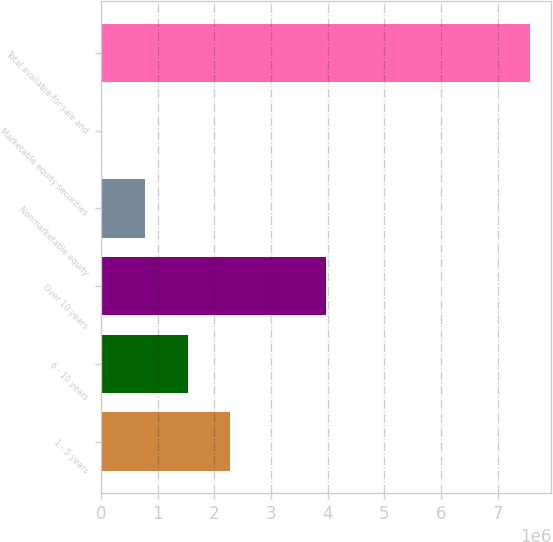Convert chart to OTSL. <chart><loc_0><loc_0><loc_500><loc_500><bar_chart><fcel>1 - 5 years<fcel>6 - 10 years<fcel>Over 10 years<fcel>Nonmarketable equity<fcel>Marketable equity securities<fcel>Total available-for-sale and<nl><fcel>2.28188e+06<fcel>1.52698e+06<fcel>3.9672e+06<fcel>772077<fcel>17177<fcel>7.56618e+06<nl></chart> 